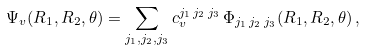<formula> <loc_0><loc_0><loc_500><loc_500>\Psi _ { v } ( R _ { 1 } , R _ { 2 } , \theta ) = \sum _ { j _ { 1 } , j _ { 2 } , j _ { 3 } } c _ { v } ^ { j _ { 1 } \, j _ { 2 } \, j _ { 3 } } \, \Phi _ { j _ { 1 } \, j _ { 2 } \, j _ { 3 } } ( R _ { 1 } , R _ { 2 } , \theta ) \, ,</formula> 